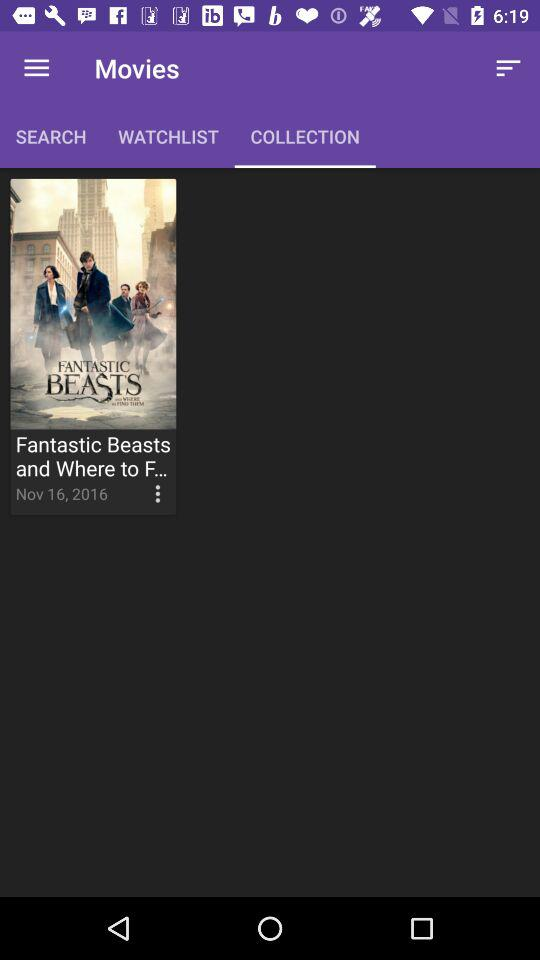What is the date given for the movie from the collection list? The date given is November 16, 2016. 